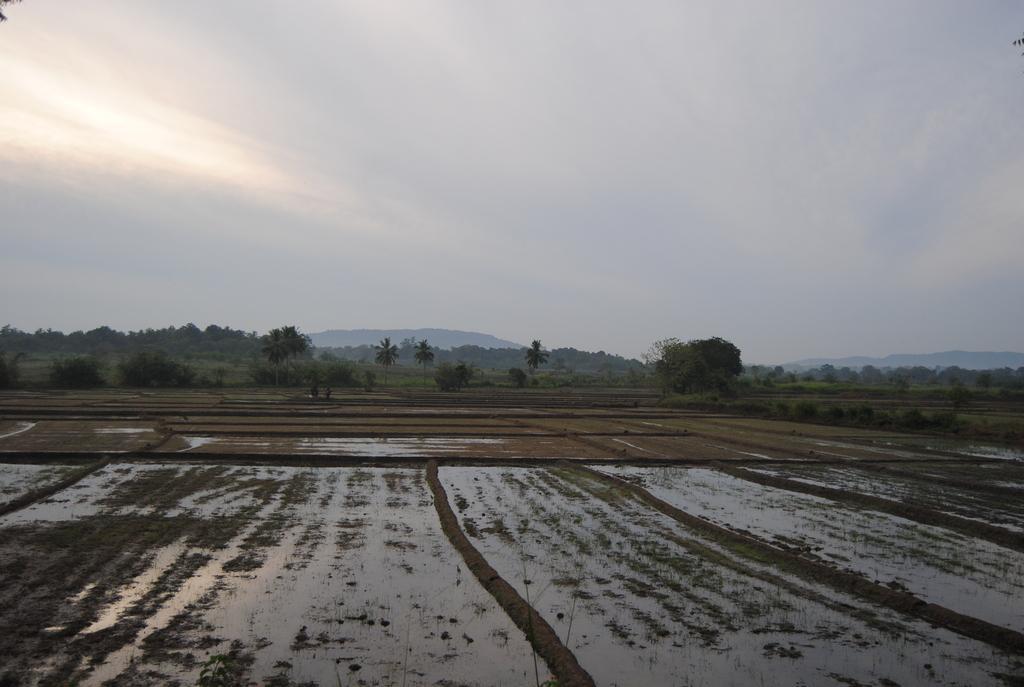Can you describe this image briefly? In this image in the front there is water. In the background there are trees and the sky is cloudy. 